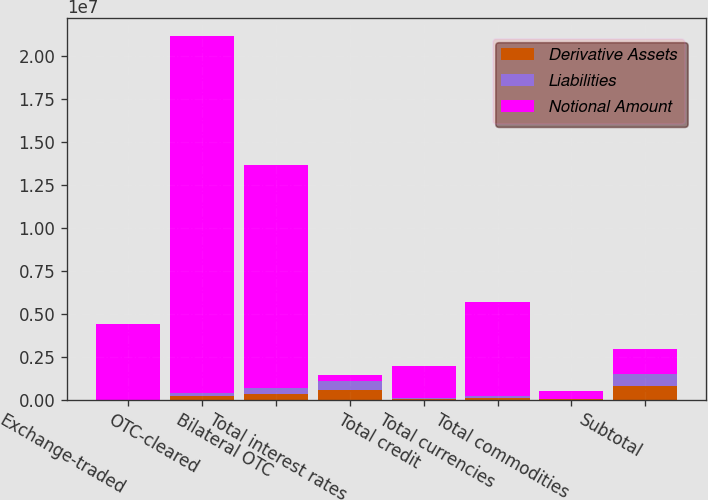Convert chart. <chart><loc_0><loc_0><loc_500><loc_500><stacked_bar_chart><ecel><fcel>Exchange-traded<fcel>OTC-cleared<fcel>Bilateral OTC<fcel>Total interest rates<fcel>Total credit<fcel>Total currencies<fcel>Total commodities<fcel>Subtotal<nl><fcel>Derivative Assets<fcel>310<fcel>211272<fcel>345516<fcel>557098<fcel>40882<fcel>97008<fcel>20674<fcel>762822<nl><fcel>Liabilities<fcel>280<fcel>192401<fcel>321458<fcel>514139<fcel>36775<fcel>99567<fcel>21071<fcel>717750<nl><fcel>Notional Amount<fcel>4.40284e+06<fcel>2.07387e+07<fcel>1.29538e+07<fcel>345516<fcel>1.89205e+06<fcel>5.48963e+06<fcel>437054<fcel>1.4555e+06<nl></chart> 